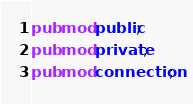Convert code to text. <code><loc_0><loc_0><loc_500><loc_500><_Rust_>


pub mod public;
pub mod private;
pub mod connection;</code> 